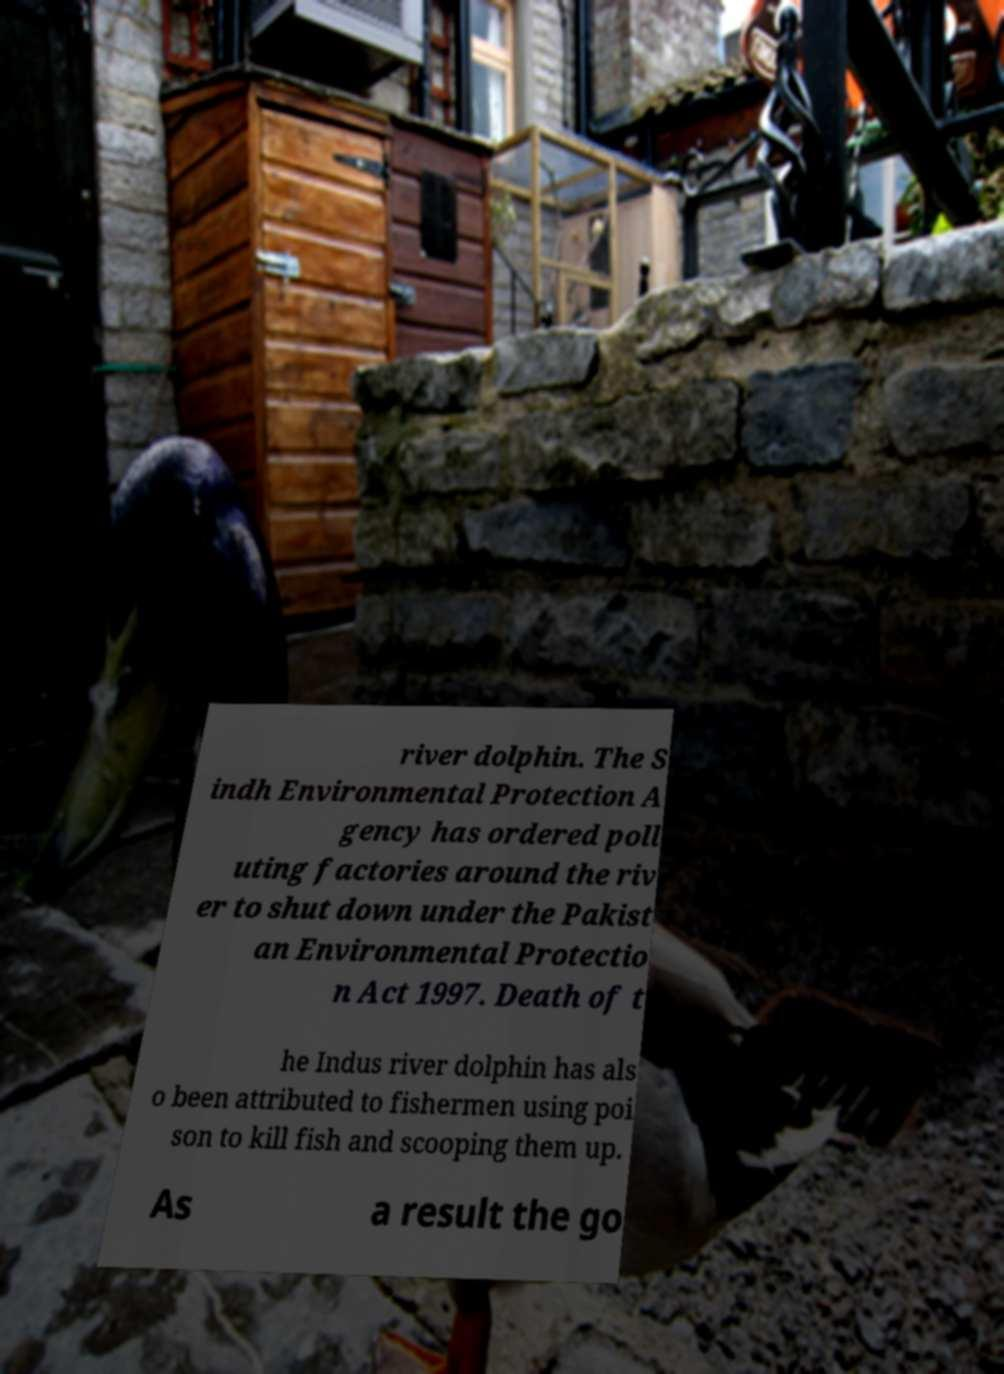For documentation purposes, I need the text within this image transcribed. Could you provide that? river dolphin. The S indh Environmental Protection A gency has ordered poll uting factories around the riv er to shut down under the Pakist an Environmental Protectio n Act 1997. Death of t he Indus river dolphin has als o been attributed to fishermen using poi son to kill fish and scooping them up. As a result the go 